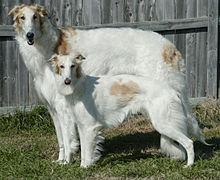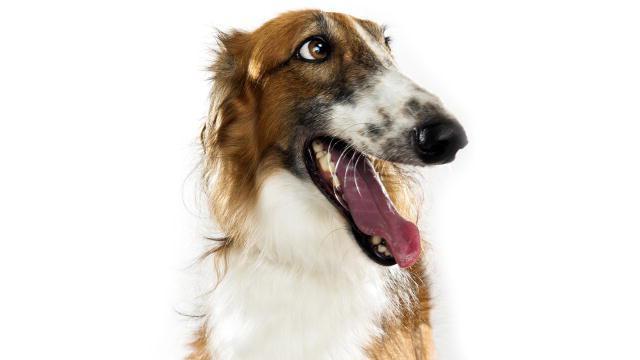The first image is the image on the left, the second image is the image on the right. Given the left and right images, does the statement "there are two dogs standing in the grass with a wall behind them" hold true? Answer yes or no. Yes. The first image is the image on the left, the second image is the image on the right. Evaluate the accuracy of this statement regarding the images: "In one image, there are two dogs standing next to each other with their bodies facing the left.". Is it true? Answer yes or no. Yes. 